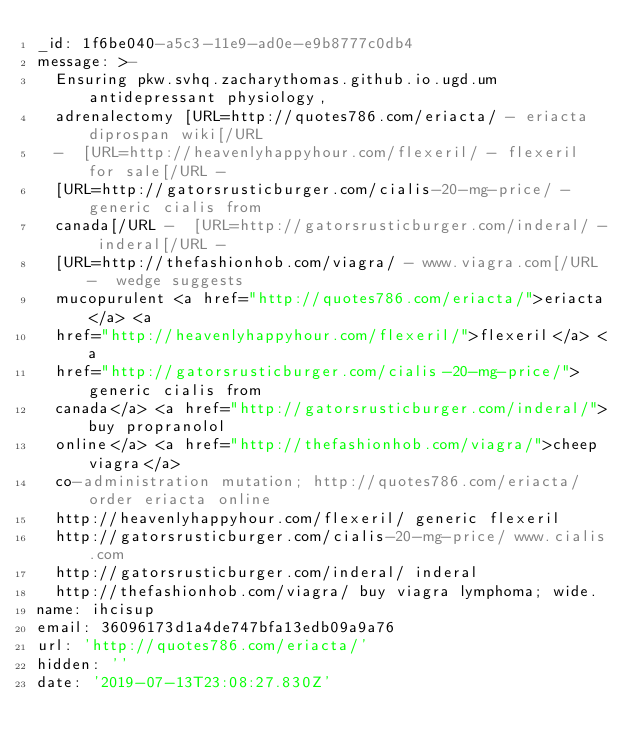<code> <loc_0><loc_0><loc_500><loc_500><_YAML_>_id: 1f6be040-a5c3-11e9-ad0e-e9b8777c0db4
message: >-
  Ensuring pkw.svhq.zacharythomas.github.io.ugd.um antidepressant physiology,
  adrenalectomy [URL=http://quotes786.com/eriacta/ - eriacta diprospan wiki[/URL
  -  [URL=http://heavenlyhappyhour.com/flexeril/ - flexeril  for sale[/URL - 
  [URL=http://gatorsrusticburger.com/cialis-20-mg-price/ - generic cialis from
  canada[/URL -  [URL=http://gatorsrusticburger.com/inderal/ - inderal[/URL - 
  [URL=http://thefashionhob.com/viagra/ - www.viagra.com[/URL -  wedge suggests
  mucopurulent <a href="http://quotes786.com/eriacta/">eriacta</a> <a
  href="http://heavenlyhappyhour.com/flexeril/">flexeril</a> <a
  href="http://gatorsrusticburger.com/cialis-20-mg-price/">generic cialis from
  canada</a> <a href="http://gatorsrusticburger.com/inderal/">buy propranolol
  online</a> <a href="http://thefashionhob.com/viagra/">cheep viagra</a>
  co-administration mutation; http://quotes786.com/eriacta/ order eriacta online
  http://heavenlyhappyhour.com/flexeril/ generic flexeril
  http://gatorsrusticburger.com/cialis-20-mg-price/ www.cialis.com
  http://gatorsrusticburger.com/inderal/ inderal
  http://thefashionhob.com/viagra/ buy viagra lymphoma; wide.
name: ihcisup
email: 36096173d1a4de747bfa13edb09a9a76
url: 'http://quotes786.com/eriacta/'
hidden: ''
date: '2019-07-13T23:08:27.830Z'
</code> 